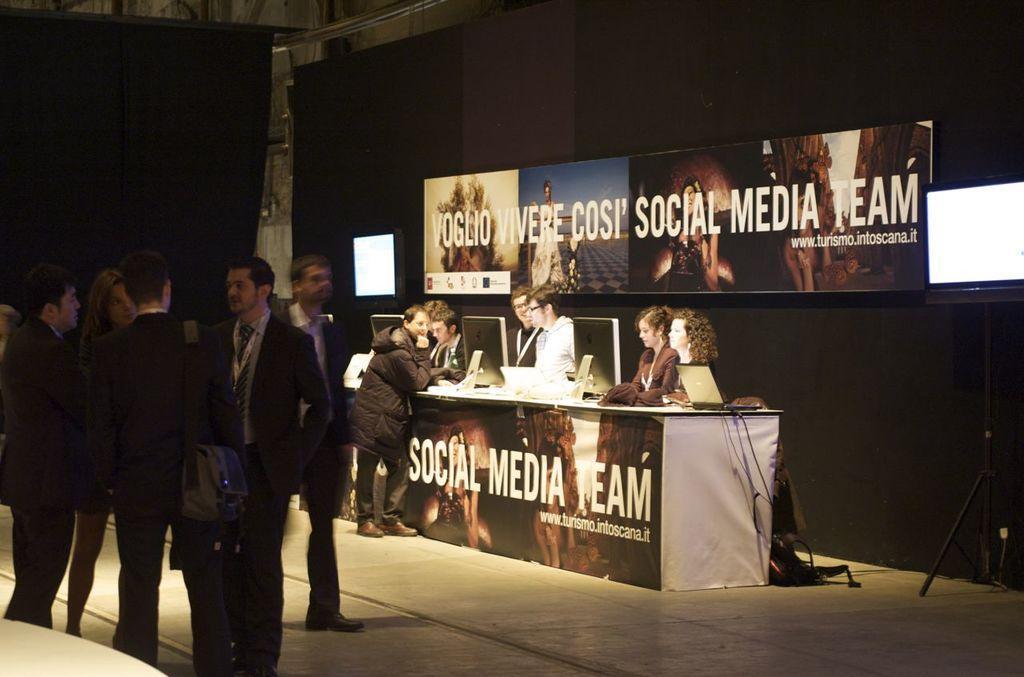Describe this image in one or two sentences. Here we can see few persons are standing on the floor. This is a table. On the table there are monitors and a laptop. Here we can see banners and screens. There is a dark background. 